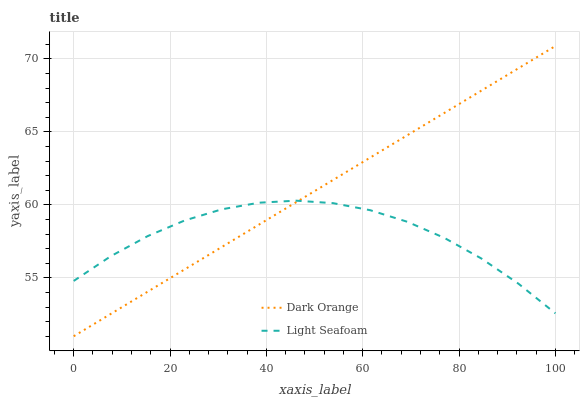Does Light Seafoam have the minimum area under the curve?
Answer yes or no. Yes. Does Dark Orange have the maximum area under the curve?
Answer yes or no. Yes. Does Light Seafoam have the maximum area under the curve?
Answer yes or no. No. Is Dark Orange the smoothest?
Answer yes or no. Yes. Is Light Seafoam the roughest?
Answer yes or no. Yes. Is Light Seafoam the smoothest?
Answer yes or no. No. Does Dark Orange have the lowest value?
Answer yes or no. Yes. Does Light Seafoam have the lowest value?
Answer yes or no. No. Does Dark Orange have the highest value?
Answer yes or no. Yes. Does Light Seafoam have the highest value?
Answer yes or no. No. Does Dark Orange intersect Light Seafoam?
Answer yes or no. Yes. Is Dark Orange less than Light Seafoam?
Answer yes or no. No. Is Dark Orange greater than Light Seafoam?
Answer yes or no. No. 